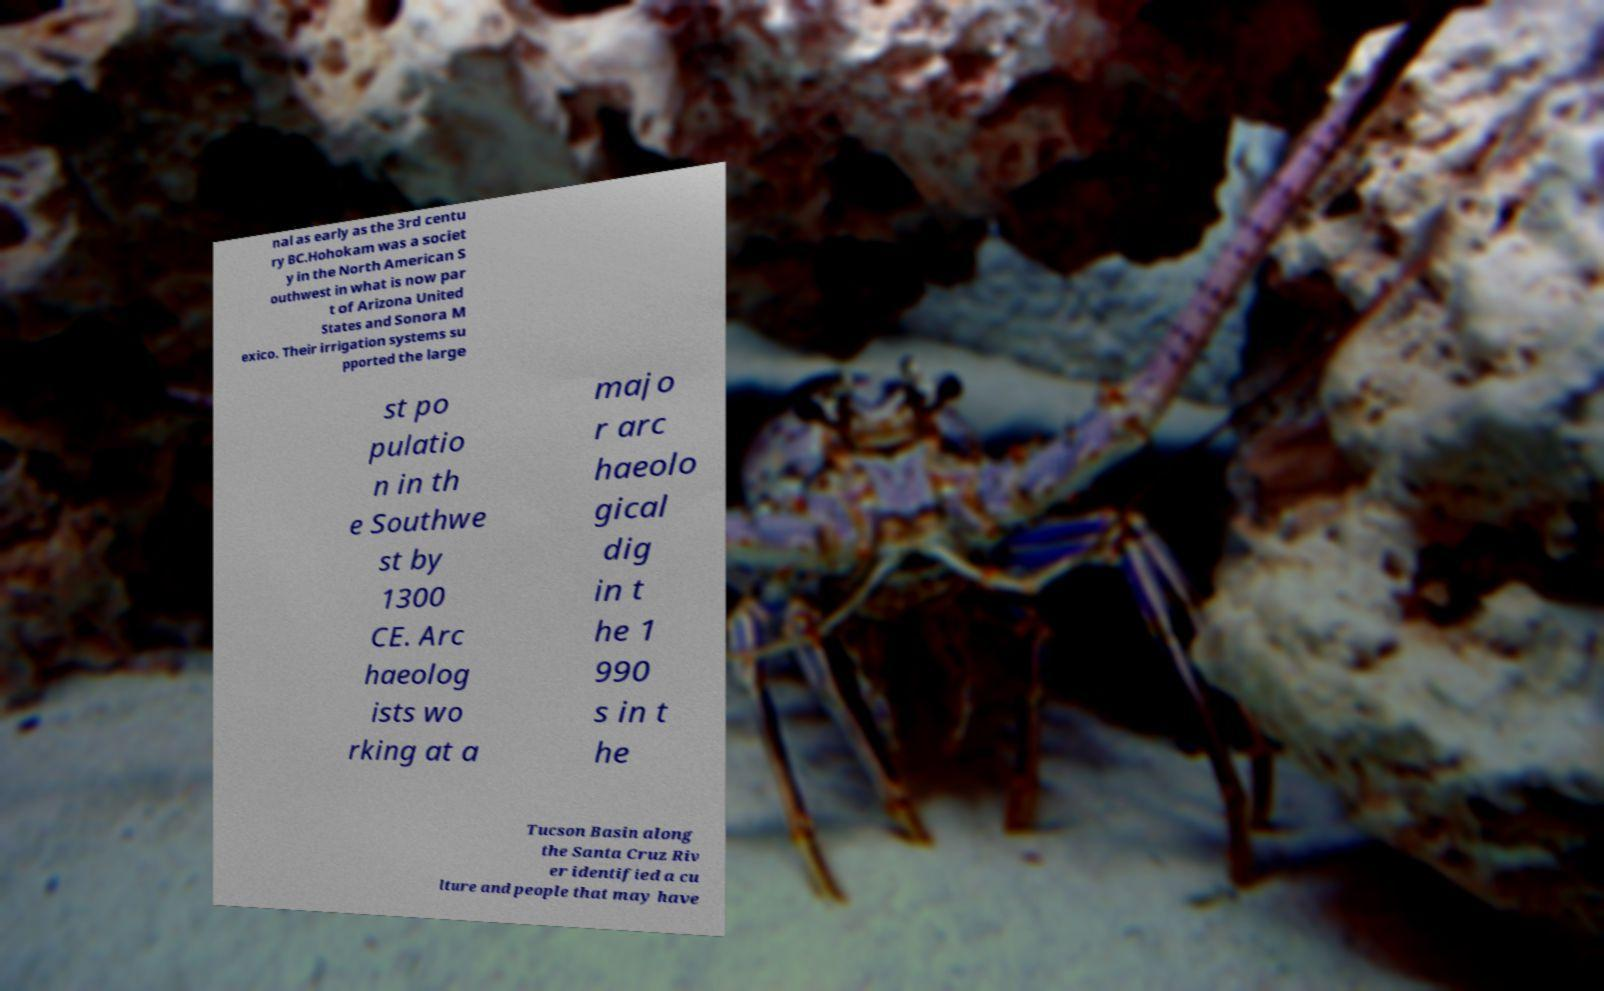Could you assist in decoding the text presented in this image and type it out clearly? nal as early as the 3rd centu ry BC.Hohokam was a societ y in the North American S outhwest in what is now par t of Arizona United States and Sonora M exico. Their irrigation systems su pported the large st po pulatio n in th e Southwe st by 1300 CE. Arc haeolog ists wo rking at a majo r arc haeolo gical dig in t he 1 990 s in t he Tucson Basin along the Santa Cruz Riv er identified a cu lture and people that may have 